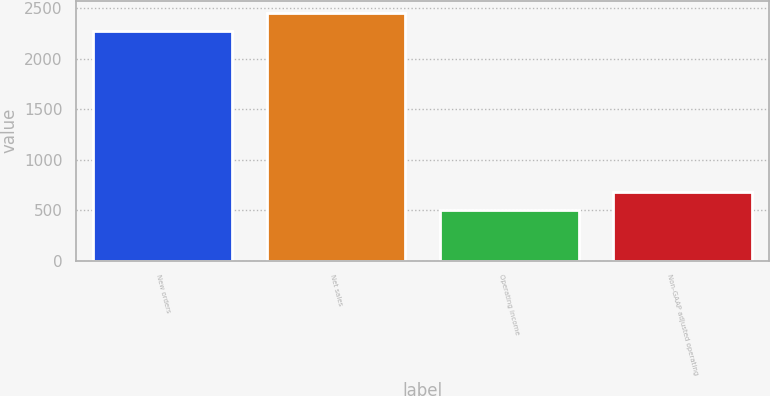Convert chart to OTSL. <chart><loc_0><loc_0><loc_500><loc_500><bar_chart><fcel>New orders<fcel>Net sales<fcel>Operating income<fcel>Non-GAAP adjusted operating<nl><fcel>2274<fcel>2452.3<fcel>502<fcel>680.3<nl></chart> 